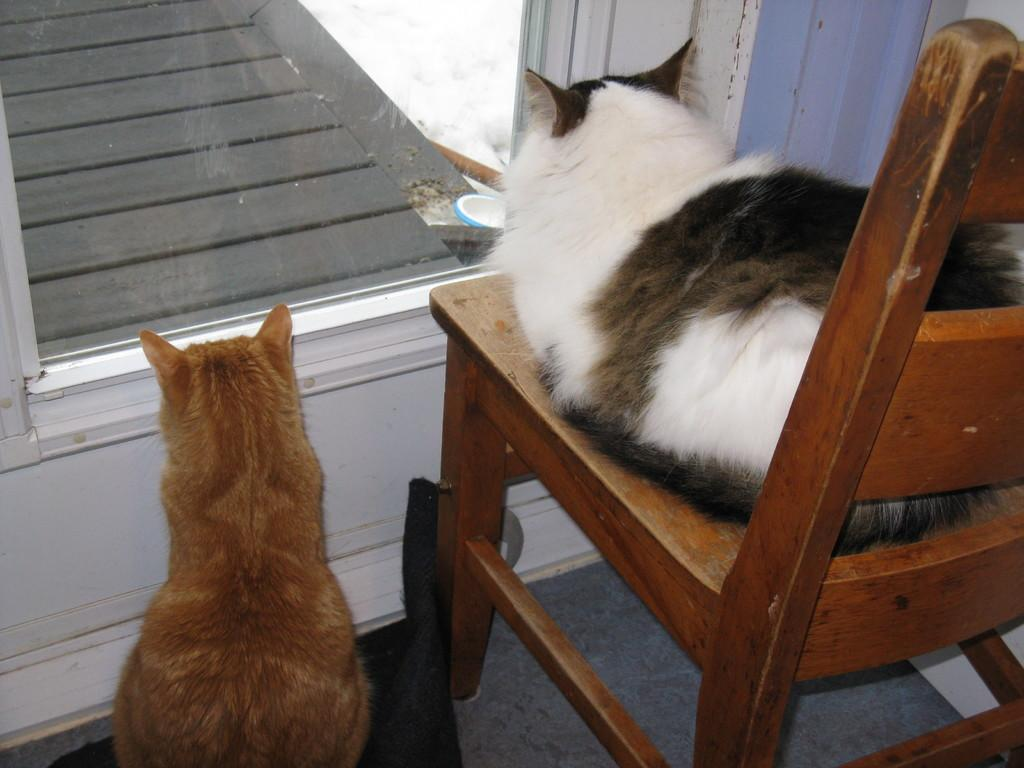How many cats are in the image? There are two cats in the image. What are the cats doing in the image? The cats are sitting. Can you see any dogs in the image? No, there are no dogs present in the image; only cats are visible. Are the cats waving at the camera in the image? No, the cats are sitting and not waving in the image. 